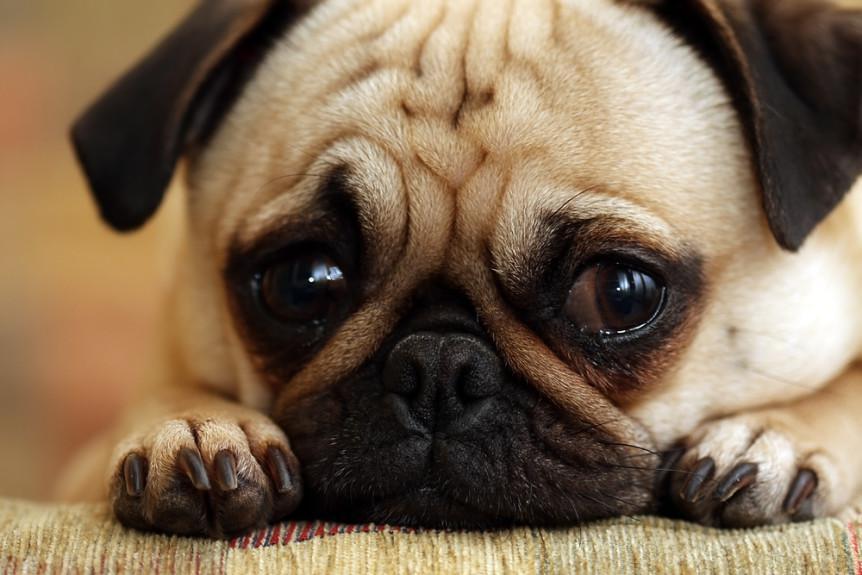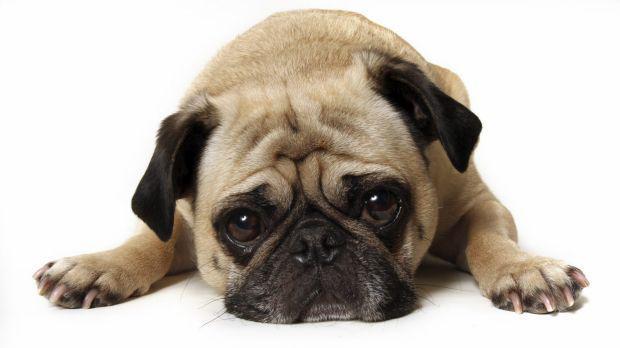The first image is the image on the left, the second image is the image on the right. For the images displayed, is the sentence "One of the images is not a living creature." factually correct? Answer yes or no. No. The first image is the image on the left, the second image is the image on the right. Analyze the images presented: Is the assertion "The left and right image contains the same number of living pugs." valid? Answer yes or no. Yes. 